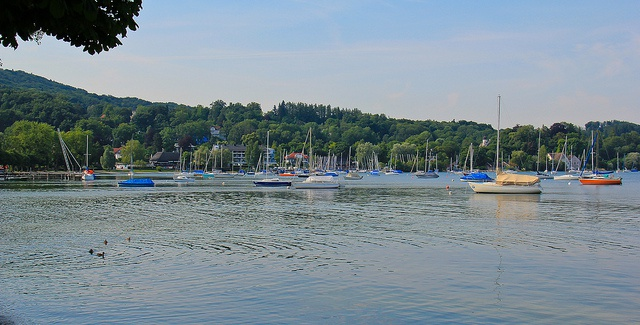Describe the objects in this image and their specific colors. I can see boat in black, gray, and darkgray tones, boat in black, darkgray, tan, and gray tones, boat in black, gray, and darkgray tones, boat in black, gray, red, and darkgray tones, and boat in black, darkgray, and gray tones in this image. 